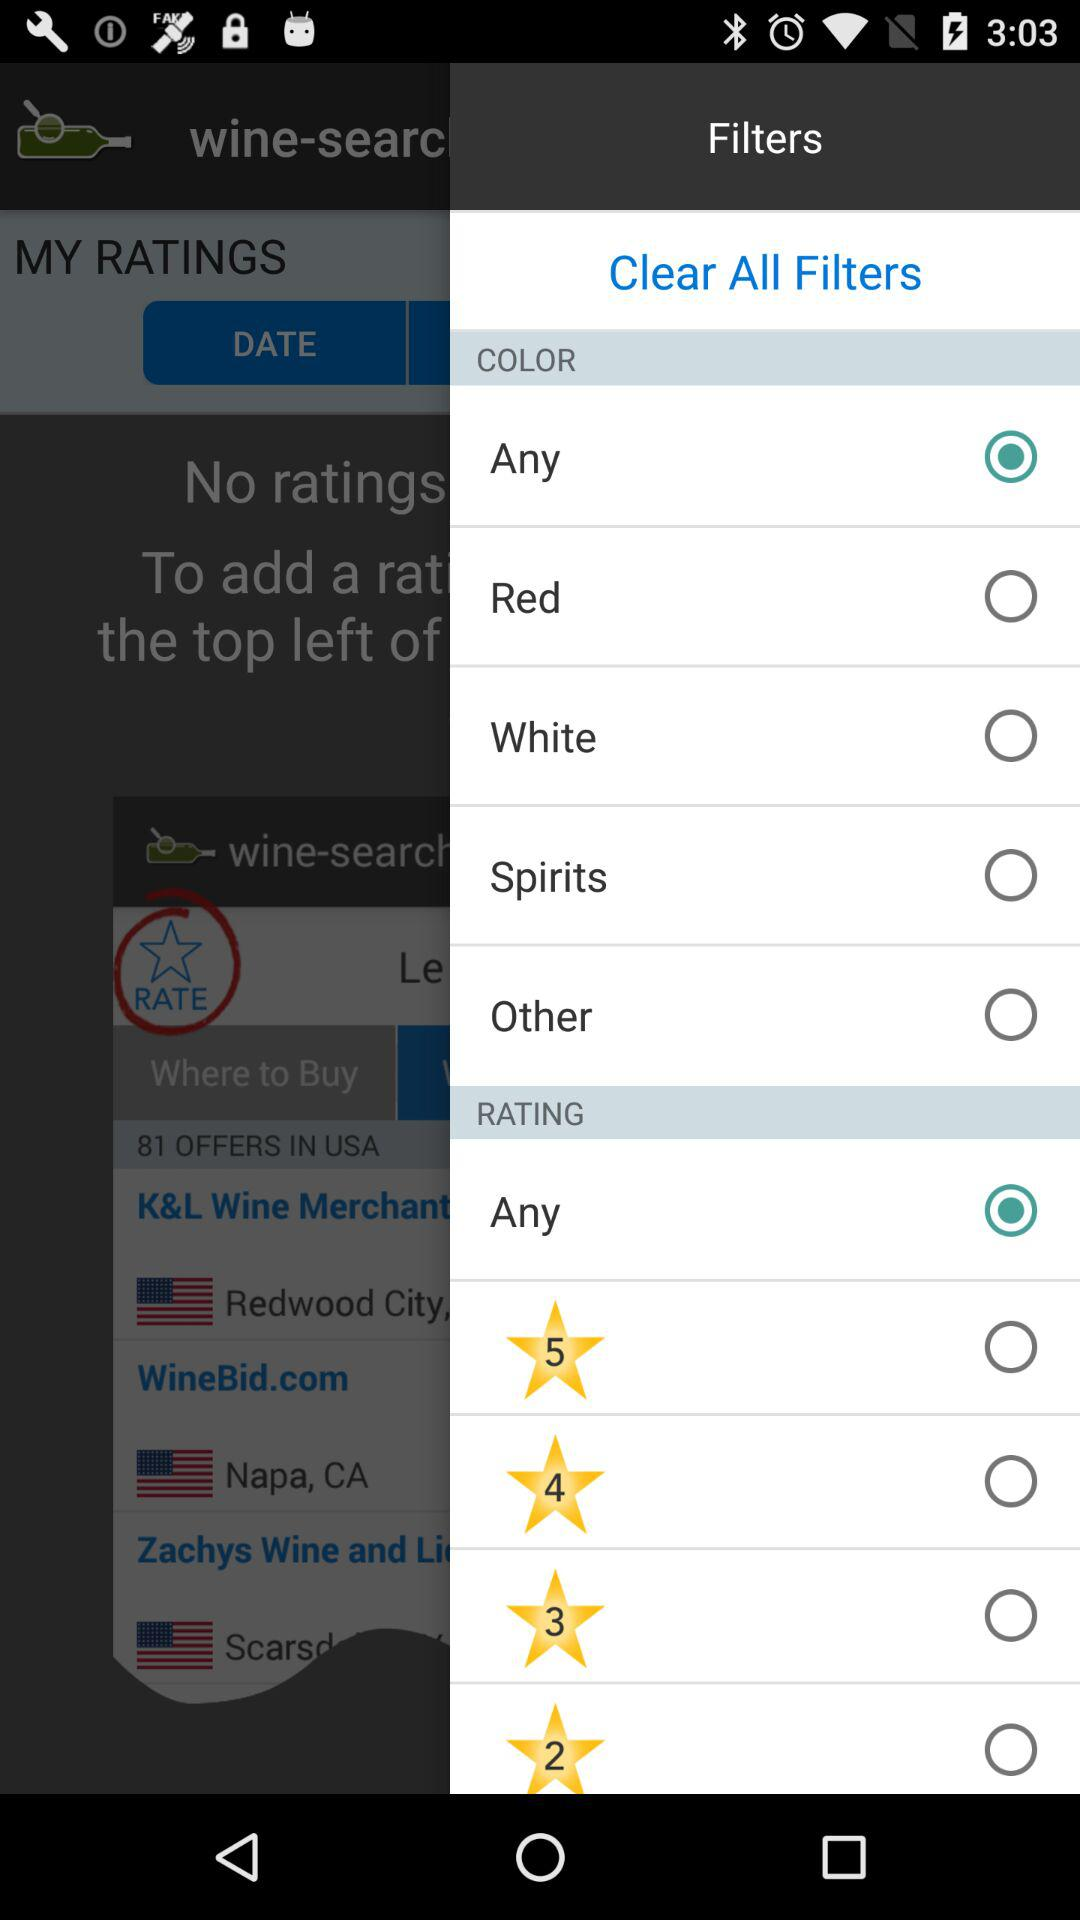What is the selected color? The selected color is "Any". 